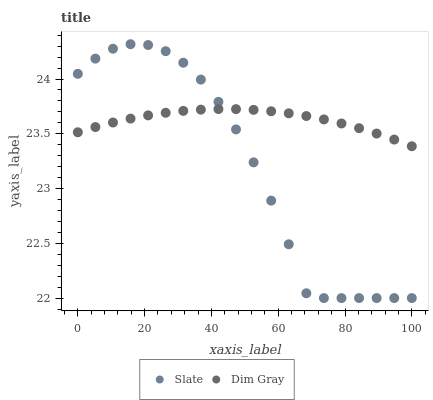Does Slate have the minimum area under the curve?
Answer yes or no. Yes. Does Dim Gray have the maximum area under the curve?
Answer yes or no. Yes. Does Dim Gray have the minimum area under the curve?
Answer yes or no. No. Is Dim Gray the smoothest?
Answer yes or no. Yes. Is Slate the roughest?
Answer yes or no. Yes. Is Dim Gray the roughest?
Answer yes or no. No. Does Slate have the lowest value?
Answer yes or no. Yes. Does Dim Gray have the lowest value?
Answer yes or no. No. Does Slate have the highest value?
Answer yes or no. Yes. Does Dim Gray have the highest value?
Answer yes or no. No. Does Dim Gray intersect Slate?
Answer yes or no. Yes. Is Dim Gray less than Slate?
Answer yes or no. No. Is Dim Gray greater than Slate?
Answer yes or no. No. 